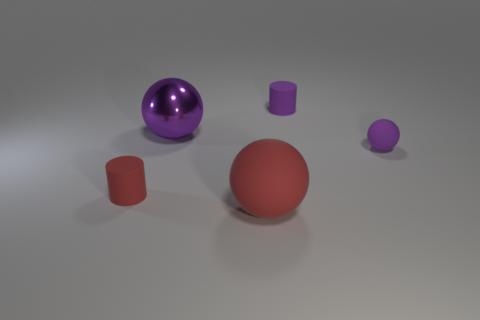Add 1 big rubber objects. How many objects exist? 6 Subtract all purple spheres. How many spheres are left? 1 Subtract all purple spheres. How many spheres are left? 1 Subtract 0 cyan spheres. How many objects are left? 5 Subtract all spheres. How many objects are left? 2 Subtract 1 cylinders. How many cylinders are left? 1 Subtract all green cylinders. Subtract all purple balls. How many cylinders are left? 2 Subtract all yellow spheres. How many yellow cylinders are left? 0 Subtract all small red matte cubes. Subtract all shiny balls. How many objects are left? 4 Add 1 large red rubber things. How many large red rubber things are left? 2 